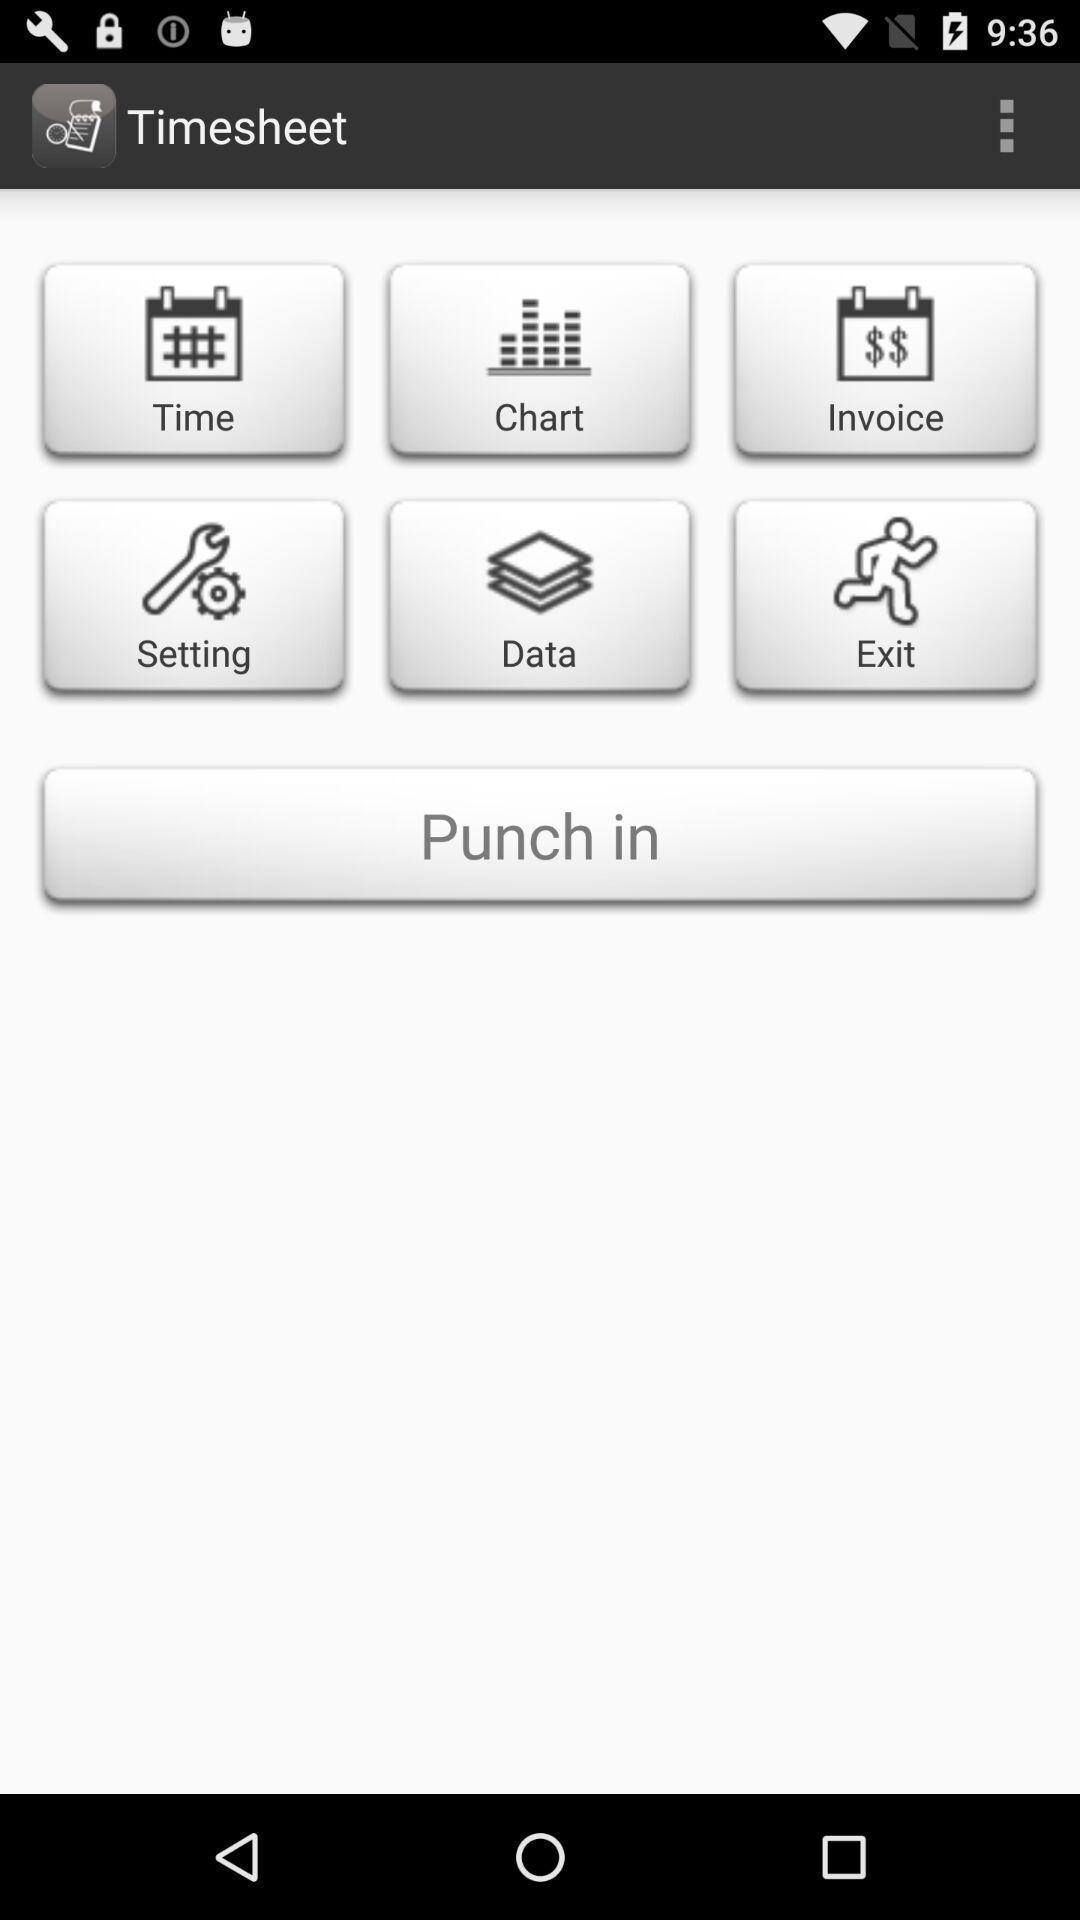Describe the key features of this screenshot. Screen shows different options. 